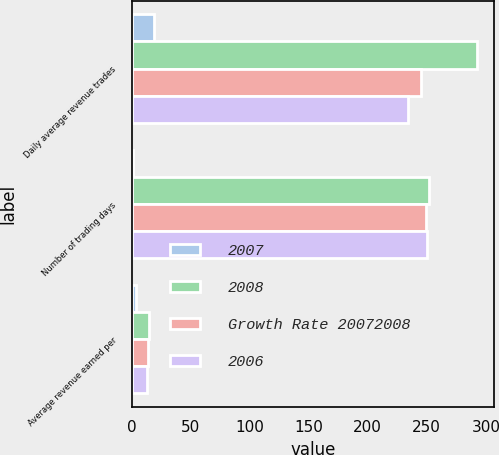Convert chart. <chart><loc_0><loc_0><loc_500><loc_500><stacked_bar_chart><ecel><fcel>Daily average revenue trades<fcel>Number of trading days<fcel>Average revenue earned per<nl><fcel>2007<fcel>19<fcel>1<fcel>4<nl><fcel>2008<fcel>292.6<fcel>251.5<fcel>14.53<nl><fcel>Growth Rate 20072008<fcel>245.3<fcel>249.5<fcel>13.99<nl><fcel>2006<fcel>234.4<fcel>250<fcel>13.39<nl></chart> 